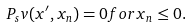Convert formula to latex. <formula><loc_0><loc_0><loc_500><loc_500>P _ { s } v ( x ^ { \prime } , x _ { n } ) = 0 f o r x _ { n } \leq 0 .</formula> 